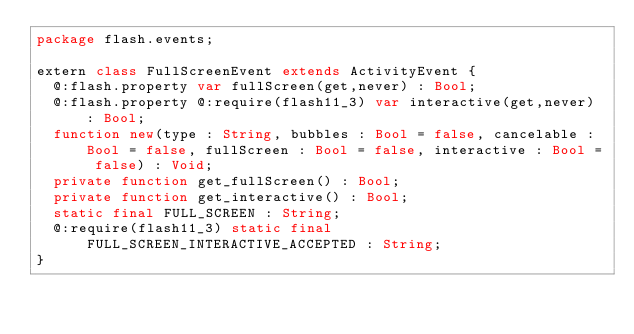<code> <loc_0><loc_0><loc_500><loc_500><_Haxe_>package flash.events;

extern class FullScreenEvent extends ActivityEvent {
	@:flash.property var fullScreen(get,never) : Bool;
	@:flash.property @:require(flash11_3) var interactive(get,never) : Bool;
	function new(type : String, bubbles : Bool = false, cancelable : Bool = false, fullScreen : Bool = false, interactive : Bool = false) : Void;
	private function get_fullScreen() : Bool;
	private function get_interactive() : Bool;
	static final FULL_SCREEN : String;
	@:require(flash11_3) static final FULL_SCREEN_INTERACTIVE_ACCEPTED : String;
}
</code> 